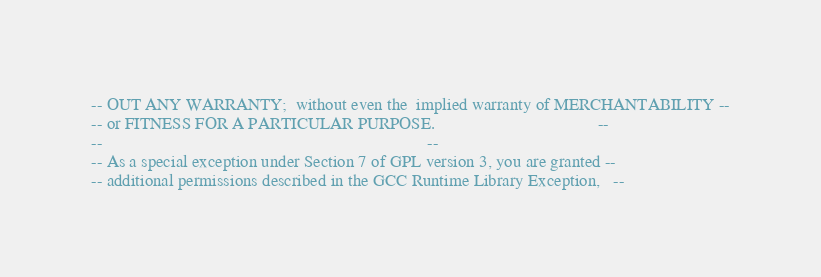<code> <loc_0><loc_0><loc_500><loc_500><_Ada_>-- OUT ANY WARRANTY;  without even the  implied warranty of MERCHANTABILITY --
-- or FITNESS FOR A PARTICULAR PURPOSE.                                     --
--                                                                          --
-- As a special exception under Section 7 of GPL version 3, you are granted --
-- additional permissions described in the GCC Runtime Library Exception,   --</code> 